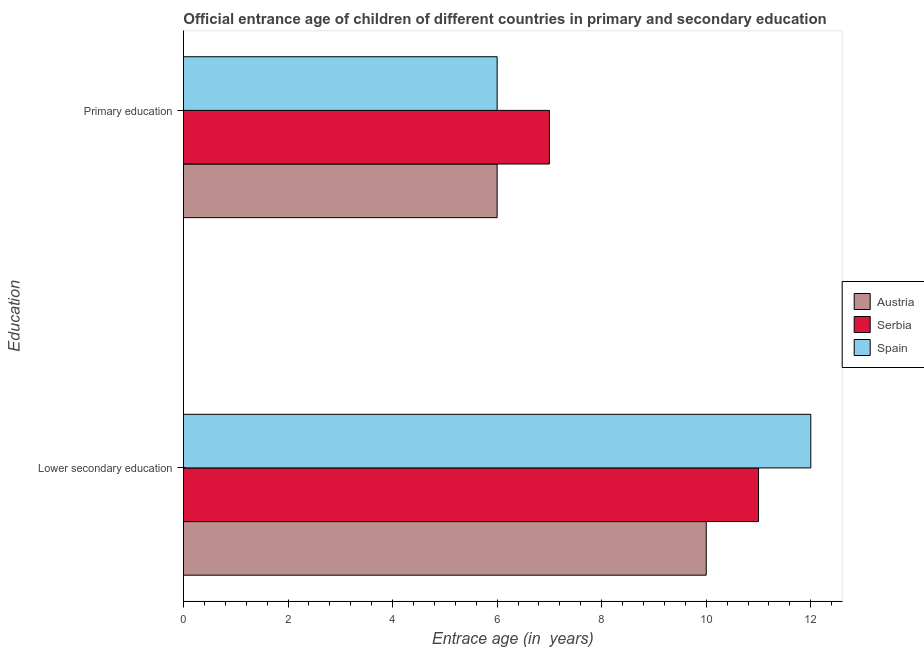How many different coloured bars are there?
Your response must be concise. 3. How many groups of bars are there?
Your answer should be compact. 2. How many bars are there on the 2nd tick from the bottom?
Your answer should be very brief. 3. What is the label of the 2nd group of bars from the top?
Provide a short and direct response. Lower secondary education. What is the entrance age of children in lower secondary education in Spain?
Provide a succinct answer. 12. Across all countries, what is the maximum entrance age of children in lower secondary education?
Ensure brevity in your answer.  12. Across all countries, what is the minimum entrance age of chiildren in primary education?
Offer a very short reply. 6. In which country was the entrance age of chiildren in primary education maximum?
Offer a very short reply. Serbia. What is the total entrance age of children in lower secondary education in the graph?
Ensure brevity in your answer.  33. What is the difference between the entrance age of children in lower secondary education in Serbia and that in Spain?
Provide a succinct answer. -1. What is the difference between the entrance age of chiildren in primary education in Spain and the entrance age of children in lower secondary education in Austria?
Keep it short and to the point. -4. What is the average entrance age of chiildren in primary education per country?
Provide a succinct answer. 6.33. What is the difference between the entrance age of children in lower secondary education and entrance age of chiildren in primary education in Serbia?
Give a very brief answer. 4. What is the ratio of the entrance age of children in lower secondary education in Austria to that in Serbia?
Your answer should be compact. 0.91. Is the entrance age of chiildren in primary education in Serbia less than that in Austria?
Keep it short and to the point. No. In how many countries, is the entrance age of children in lower secondary education greater than the average entrance age of children in lower secondary education taken over all countries?
Your response must be concise. 1. What does the 2nd bar from the top in Lower secondary education represents?
Give a very brief answer. Serbia. What does the 2nd bar from the bottom in Primary education represents?
Keep it short and to the point. Serbia. Are all the bars in the graph horizontal?
Your answer should be compact. Yes. Are the values on the major ticks of X-axis written in scientific E-notation?
Offer a terse response. No. Does the graph contain any zero values?
Give a very brief answer. No. Does the graph contain grids?
Your answer should be compact. No. Where does the legend appear in the graph?
Offer a very short reply. Center right. How are the legend labels stacked?
Give a very brief answer. Vertical. What is the title of the graph?
Give a very brief answer. Official entrance age of children of different countries in primary and secondary education. What is the label or title of the X-axis?
Provide a short and direct response. Entrace age (in  years). What is the label or title of the Y-axis?
Your answer should be very brief. Education. What is the Entrace age (in  years) of Serbia in Lower secondary education?
Offer a terse response. 11. What is the Entrace age (in  years) of Austria in Primary education?
Your answer should be compact. 6. What is the Entrace age (in  years) in Serbia in Primary education?
Offer a very short reply. 7. What is the Entrace age (in  years) of Spain in Primary education?
Offer a very short reply. 6. Across all Education, what is the maximum Entrace age (in  years) of Serbia?
Ensure brevity in your answer.  11. Across all Education, what is the maximum Entrace age (in  years) of Spain?
Offer a very short reply. 12. What is the total Entrace age (in  years) in Austria in the graph?
Provide a succinct answer. 16. What is the total Entrace age (in  years) of Serbia in the graph?
Make the answer very short. 18. What is the total Entrace age (in  years) of Spain in the graph?
Your answer should be very brief. 18. What is the difference between the Entrace age (in  years) of Spain in Lower secondary education and that in Primary education?
Offer a very short reply. 6. What is the difference between the Entrace age (in  years) in Austria in Lower secondary education and the Entrace age (in  years) in Spain in Primary education?
Give a very brief answer. 4. What is the average Entrace age (in  years) of Spain per Education?
Keep it short and to the point. 9. What is the difference between the Entrace age (in  years) of Austria and Entrace age (in  years) of Serbia in Primary education?
Make the answer very short. -1. What is the difference between the Entrace age (in  years) in Austria and Entrace age (in  years) in Spain in Primary education?
Your answer should be compact. 0. What is the ratio of the Entrace age (in  years) of Austria in Lower secondary education to that in Primary education?
Provide a succinct answer. 1.67. What is the ratio of the Entrace age (in  years) of Serbia in Lower secondary education to that in Primary education?
Your answer should be compact. 1.57. What is the difference between the highest and the second highest Entrace age (in  years) in Austria?
Provide a succinct answer. 4. What is the difference between the highest and the second highest Entrace age (in  years) in Serbia?
Your answer should be compact. 4. What is the difference between the highest and the second highest Entrace age (in  years) in Spain?
Keep it short and to the point. 6. 